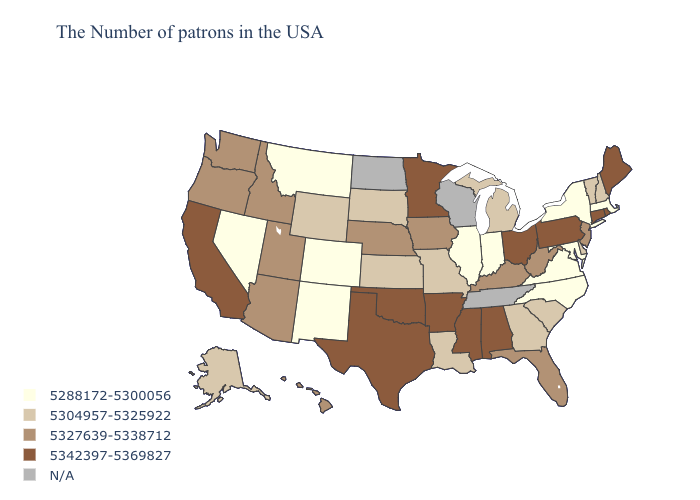Does the first symbol in the legend represent the smallest category?
Give a very brief answer. Yes. What is the value of New Hampshire?
Answer briefly. 5304957-5325922. What is the lowest value in states that border California?
Concise answer only. 5288172-5300056. Which states have the highest value in the USA?
Write a very short answer. Maine, Rhode Island, Connecticut, Pennsylvania, Ohio, Alabama, Mississippi, Arkansas, Minnesota, Oklahoma, Texas, California. What is the lowest value in the South?
Answer briefly. 5288172-5300056. Name the states that have a value in the range 5304957-5325922?
Short answer required. New Hampshire, Vermont, Delaware, South Carolina, Georgia, Michigan, Louisiana, Missouri, Kansas, South Dakota, Wyoming, Alaska. Which states have the lowest value in the USA?
Short answer required. Massachusetts, New York, Maryland, Virginia, North Carolina, Indiana, Illinois, Colorado, New Mexico, Montana, Nevada. Does California have the highest value in the West?
Short answer required. Yes. What is the lowest value in the USA?
Keep it brief. 5288172-5300056. Does the map have missing data?
Concise answer only. Yes. Does West Virginia have the highest value in the USA?
Be succinct. No. Name the states that have a value in the range 5327639-5338712?
Keep it brief. New Jersey, West Virginia, Florida, Kentucky, Iowa, Nebraska, Utah, Arizona, Idaho, Washington, Oregon, Hawaii. Which states have the lowest value in the USA?
Quick response, please. Massachusetts, New York, Maryland, Virginia, North Carolina, Indiana, Illinois, Colorado, New Mexico, Montana, Nevada. 